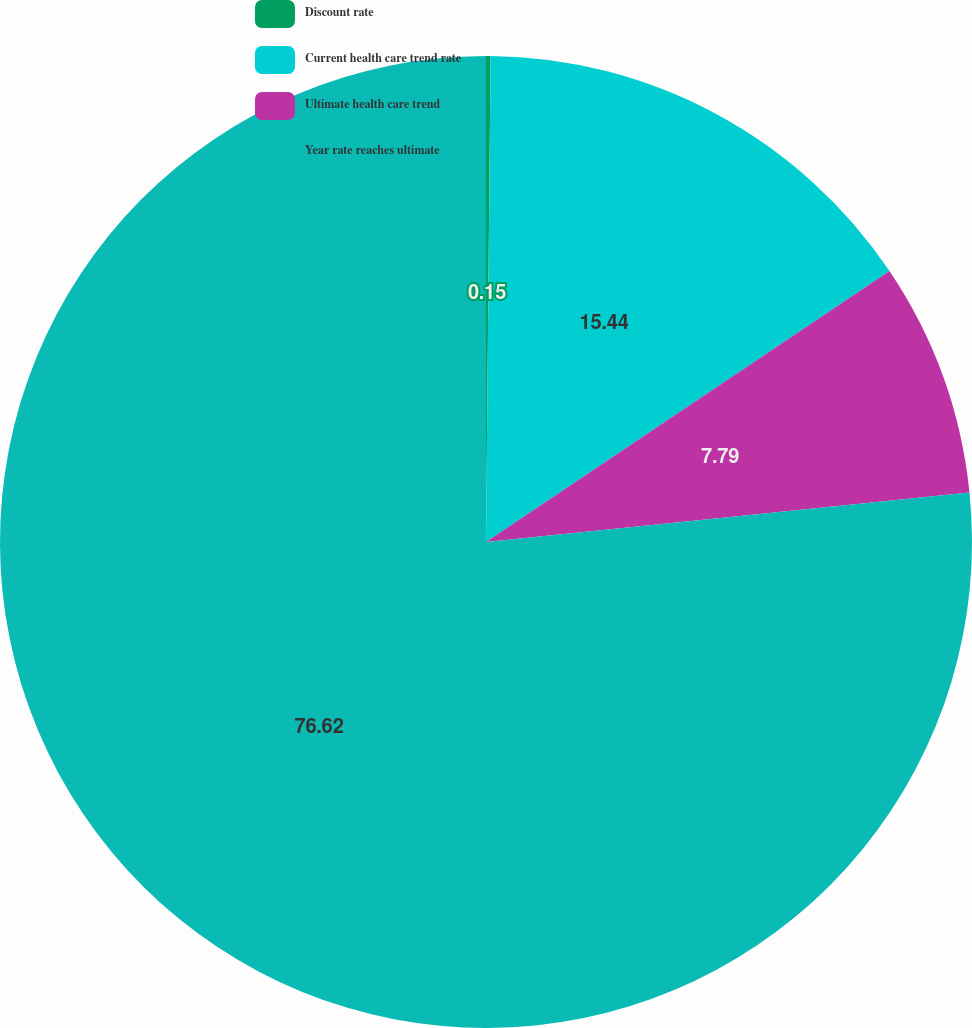Convert chart to OTSL. <chart><loc_0><loc_0><loc_500><loc_500><pie_chart><fcel>Discount rate<fcel>Current health care trend rate<fcel>Ultimate health care trend<fcel>Year rate reaches ultimate<nl><fcel>0.15%<fcel>15.44%<fcel>7.79%<fcel>76.62%<nl></chart> 